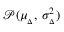<formula> <loc_0><loc_0><loc_500><loc_500>\mathcal { P } ( \mu _ { _ { \Delta } } , \, \sigma _ { _ { \Delta } } ^ { 2 } )</formula> 